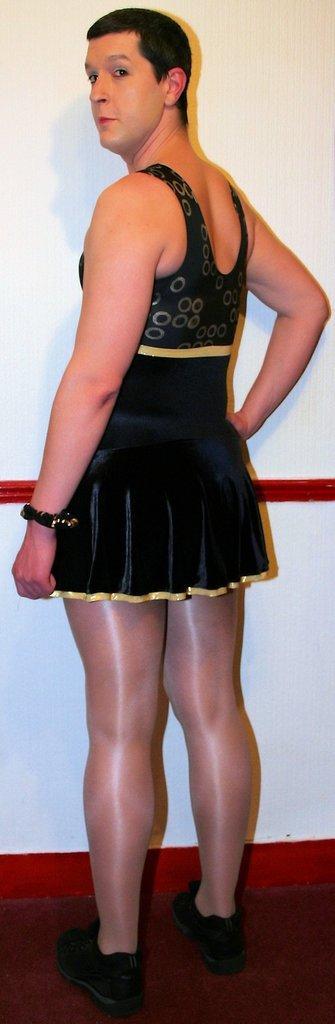Could you give a brief overview of what you see in this image? In this image we can see a person is standing on red color carpet and wearing black color dress. Background of the image white color wall is there. 